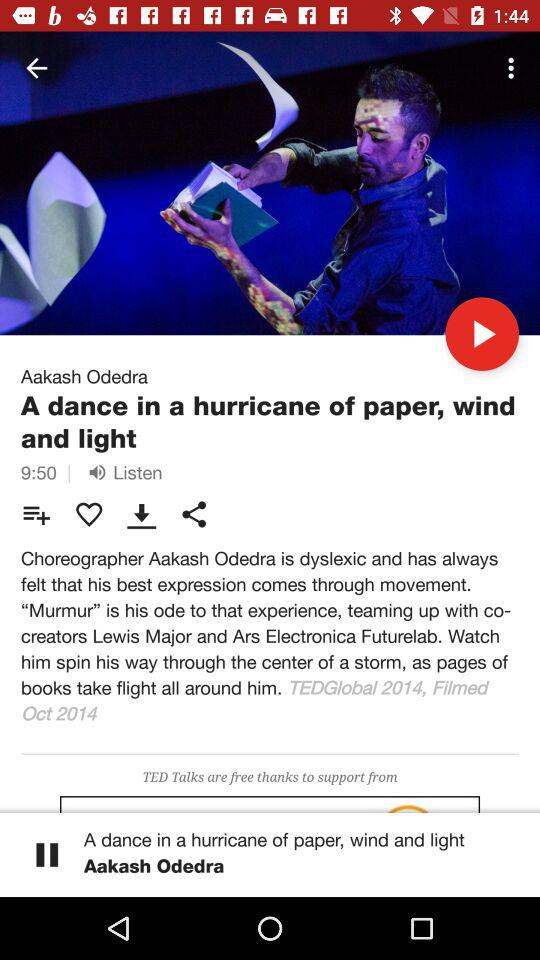What is the time duration? The time duration is 9 minutes 50 seconds. 